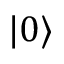Convert formula to latex. <formula><loc_0><loc_0><loc_500><loc_500>| 0 \rangle</formula> 